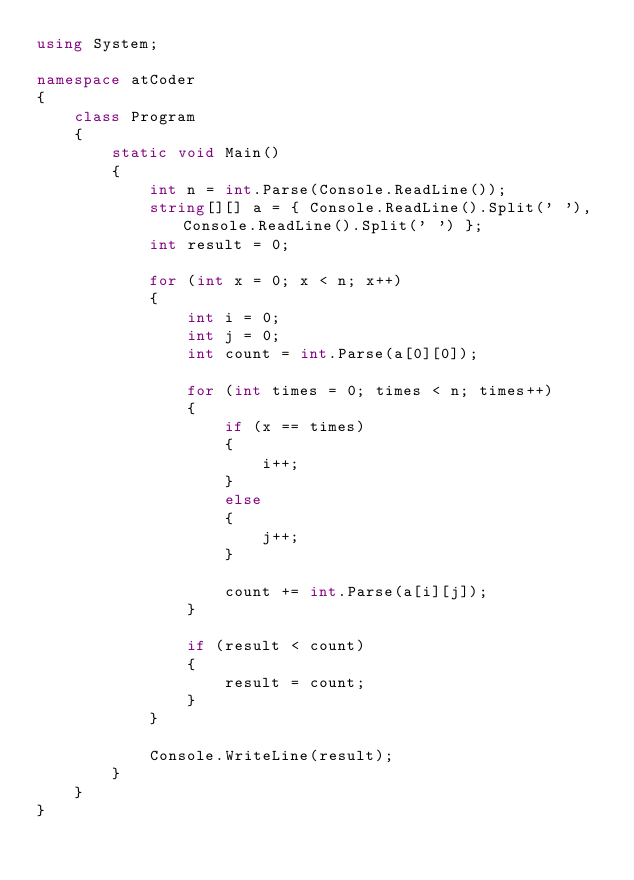Convert code to text. <code><loc_0><loc_0><loc_500><loc_500><_C#_>using System;

namespace atCoder
{
    class Program
    {
        static void Main()
        {
            int n = int.Parse(Console.ReadLine());
            string[][] a = { Console.ReadLine().Split(' '), Console.ReadLine().Split(' ') };
            int result = 0;

            for (int x = 0; x < n; x++)
            {
                int i = 0;
                int j = 0;
                int count = int.Parse(a[0][0]);

                for (int times = 0; times < n; times++)
                {
                    if (x == times)
                    {
                        i++;
                    }
                    else
                    {
                        j++;
                    }

                    count += int.Parse(a[i][j]);
                }

                if (result < count)
                {
                    result = count;
                }
            }

            Console.WriteLine(result);
        }
    }
}</code> 